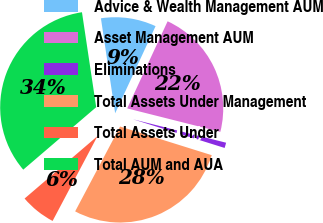Convert chart to OTSL. <chart><loc_0><loc_0><loc_500><loc_500><pie_chart><fcel>Advice & Wealth Management AUM<fcel>Asset Management AUM<fcel>Eliminations<fcel>Total Assets Under Management<fcel>Total Assets Under<fcel>Total AUM and AUA<nl><fcel>9.28%<fcel>22.01%<fcel>0.9%<fcel>27.92%<fcel>5.98%<fcel>33.9%<nl></chart> 